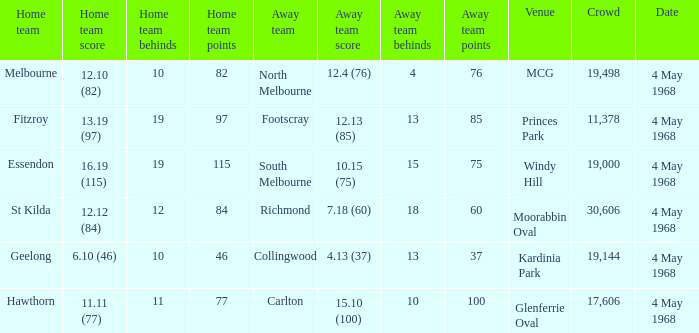What away team played at Kardinia Park? 4.13 (37). 